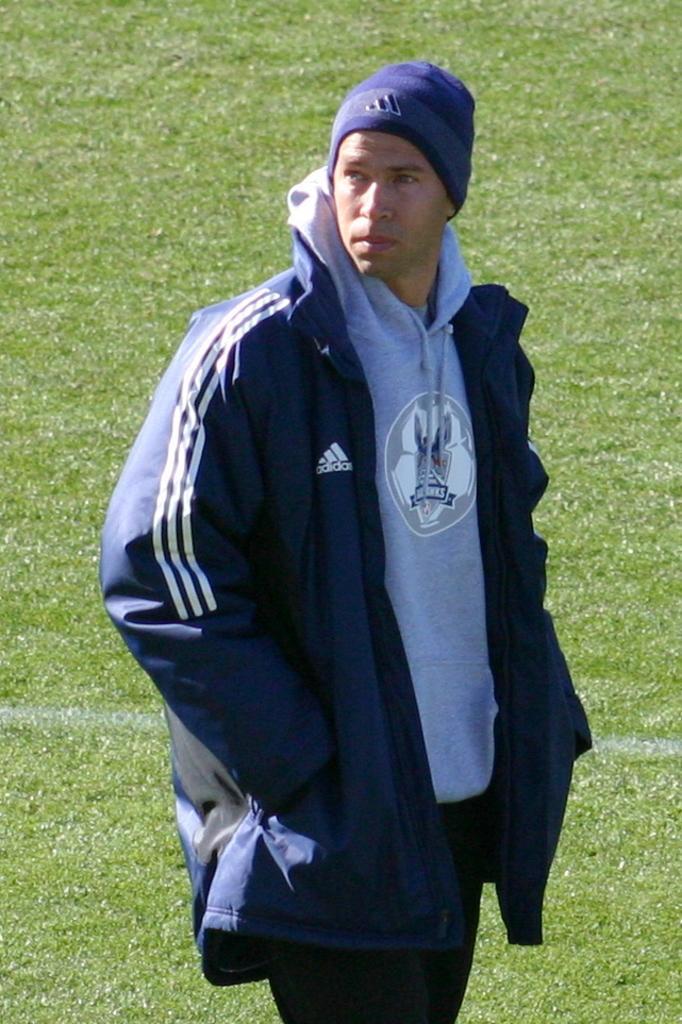Could you give a brief overview of what you see in this image? In this picture there is a man in blue jacket and a cap. In the picture there is grass. It is a sunny day. 